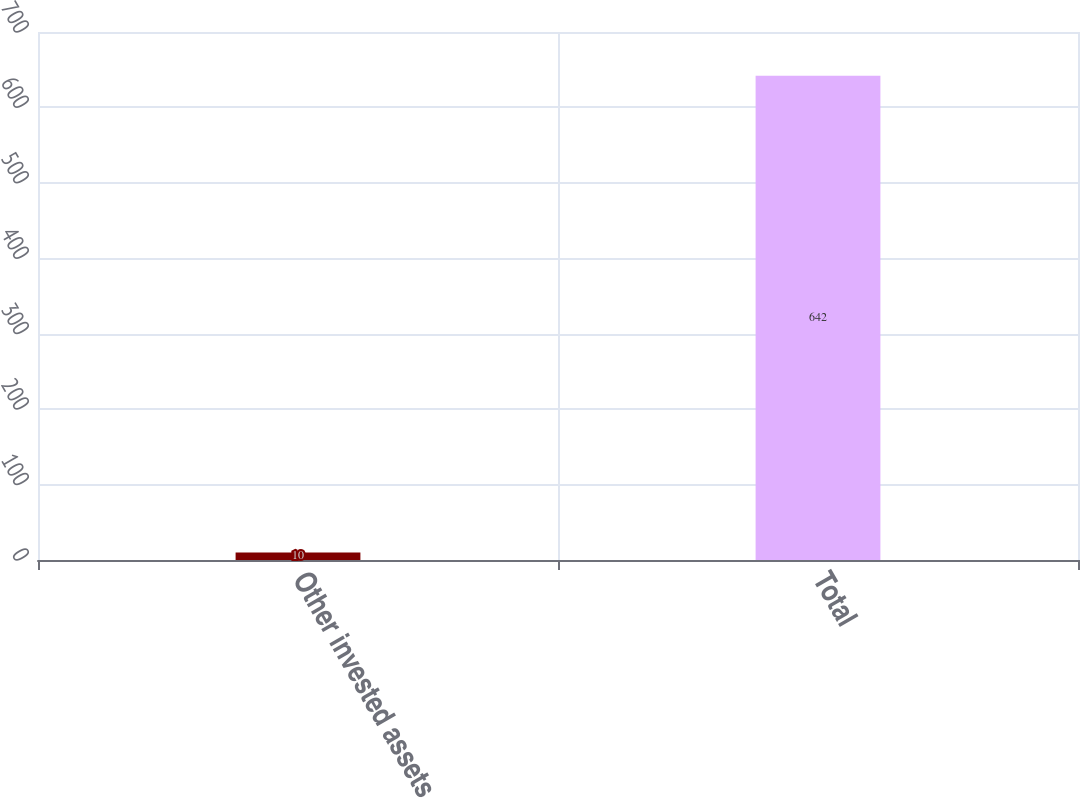<chart> <loc_0><loc_0><loc_500><loc_500><bar_chart><fcel>Other invested assets<fcel>Total<nl><fcel>10<fcel>642<nl></chart> 